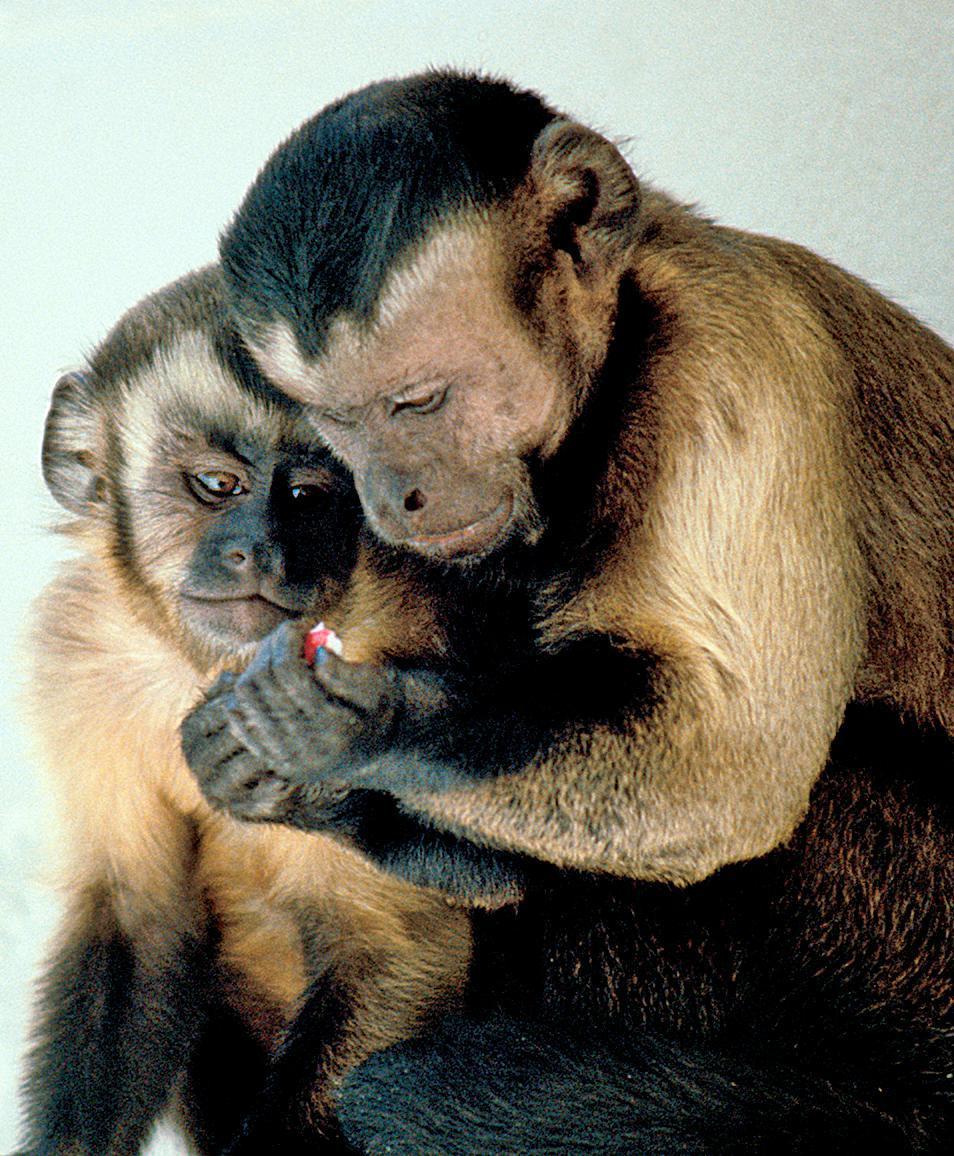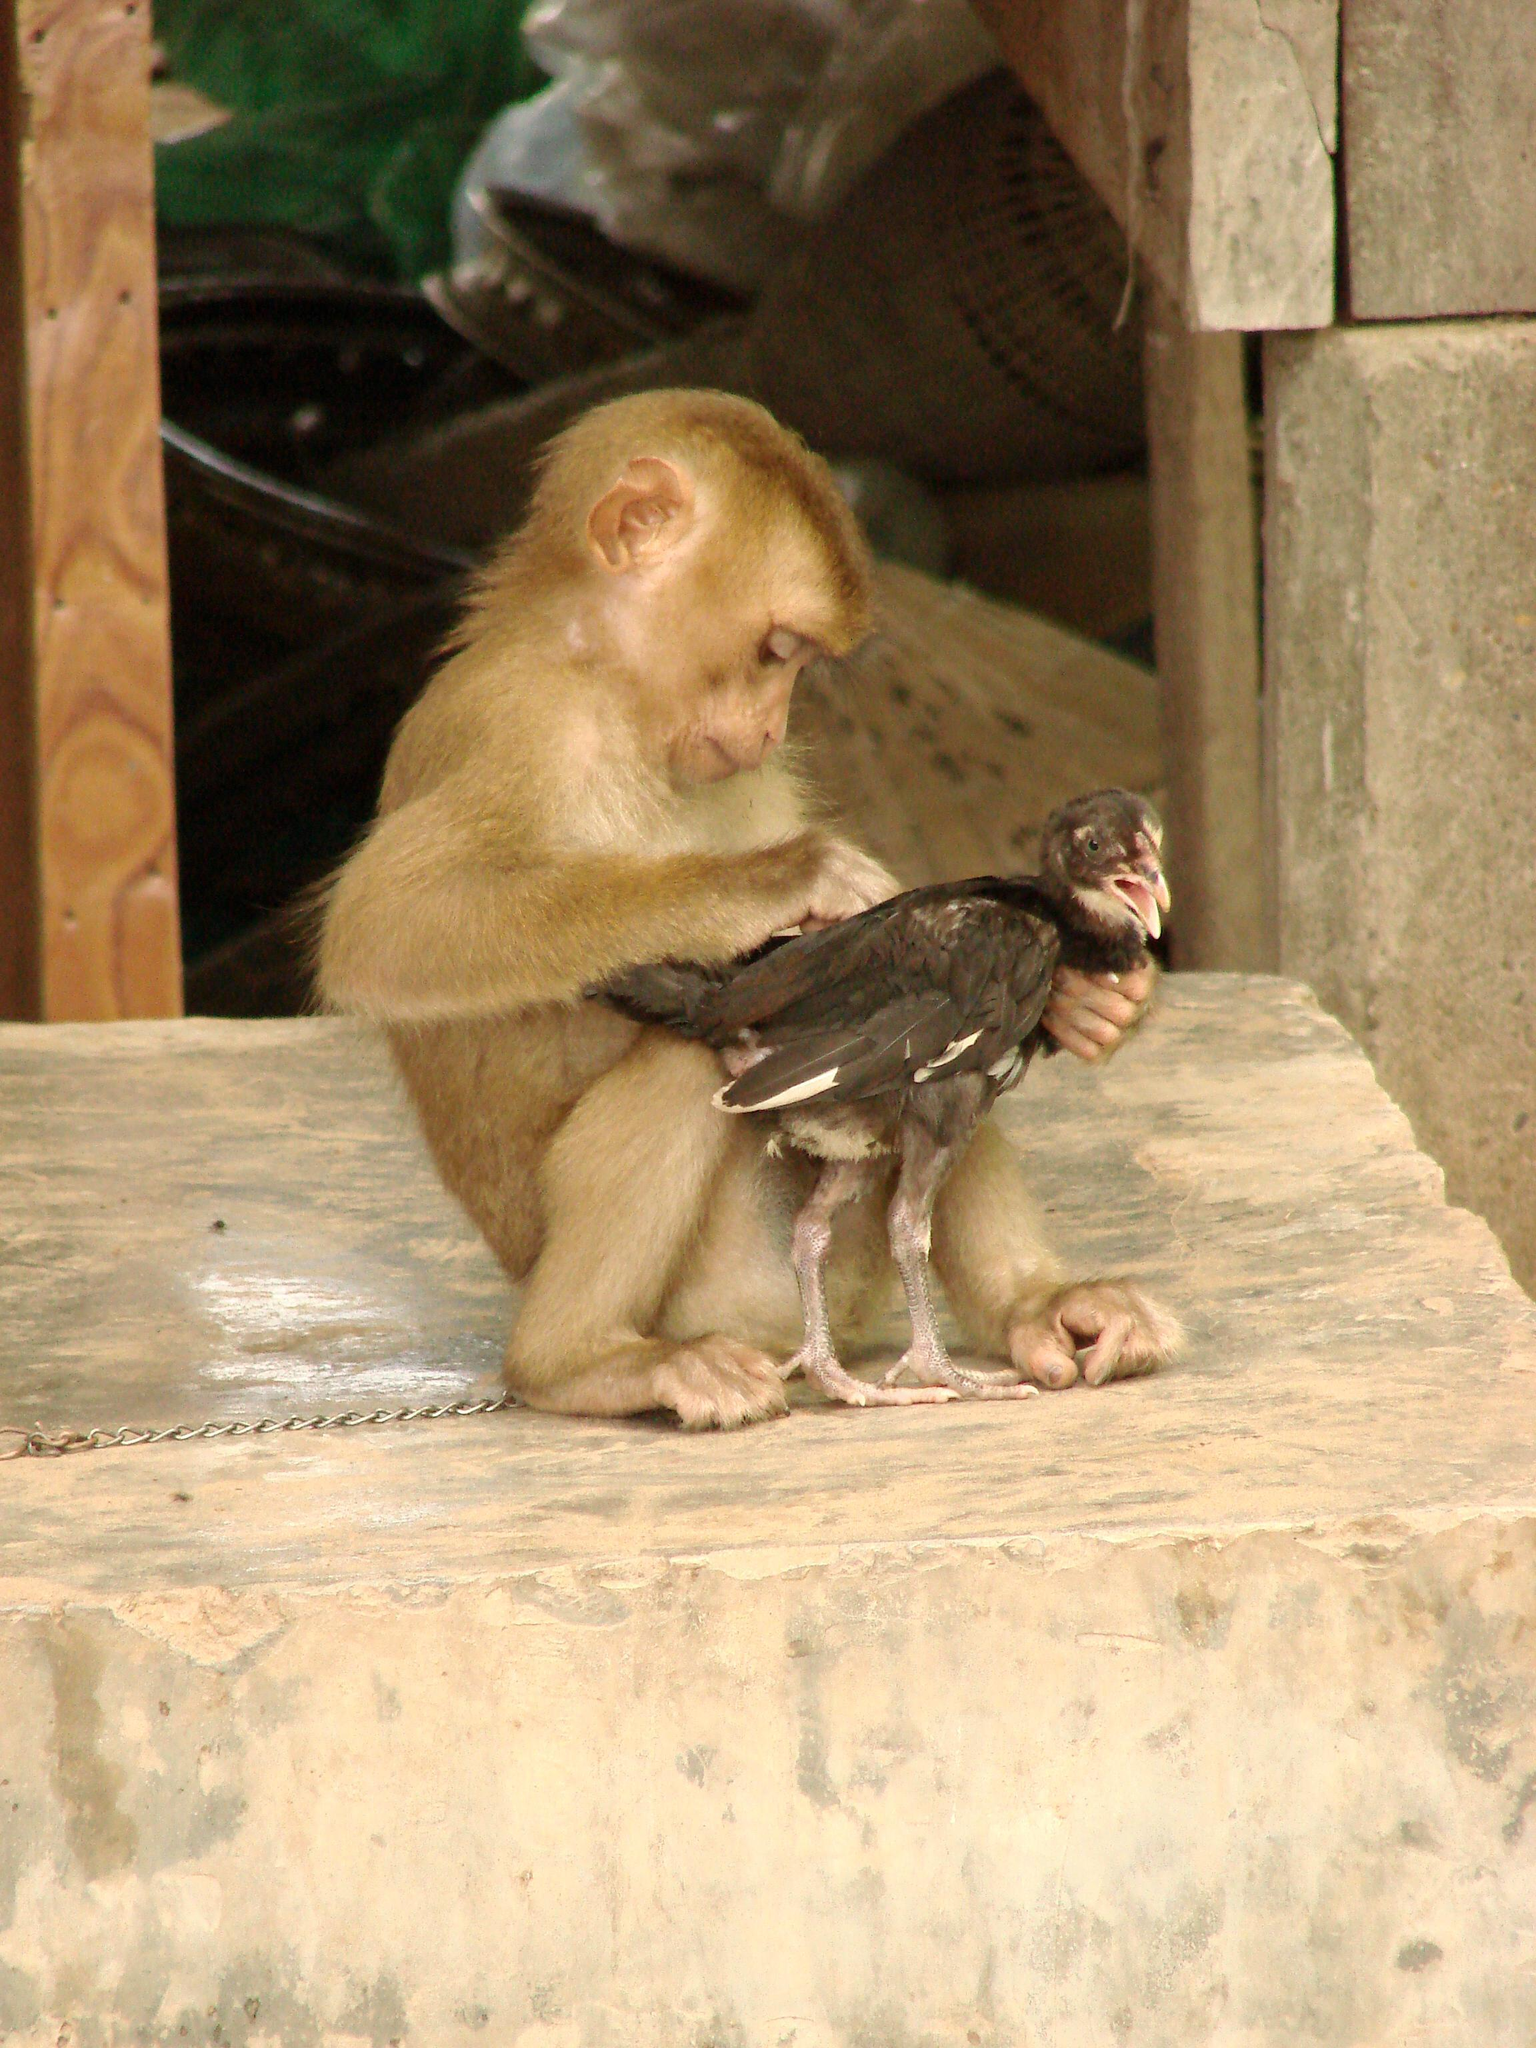The first image is the image on the left, the second image is the image on the right. Assess this claim about the two images: "Each image shows two animals interacting, and one image shows a monkey grooming the animal next to it.". Correct or not? Answer yes or no. Yes. The first image is the image on the left, the second image is the image on the right. Examine the images to the left and right. Is the description "There are exactly three apes." accurate? Answer yes or no. Yes. 